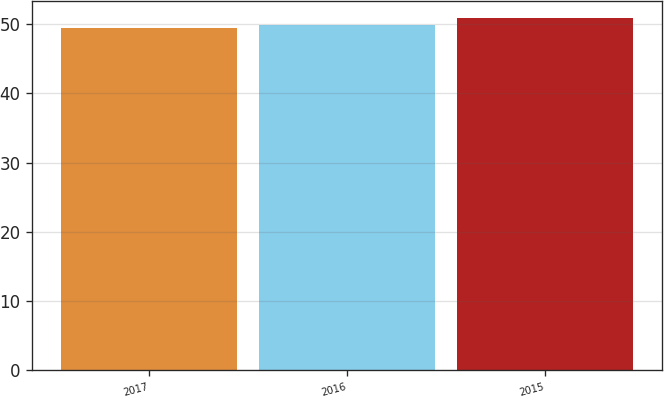Convert chart to OTSL. <chart><loc_0><loc_0><loc_500><loc_500><bar_chart><fcel>2017<fcel>2016<fcel>2015<nl><fcel>49.4<fcel>49.8<fcel>50.8<nl></chart> 